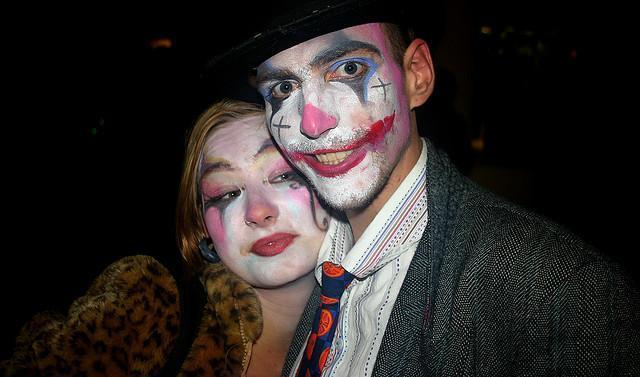How many people are visible?
Give a very brief answer. 2. How many of the cats paws are on the desk?
Give a very brief answer. 0. 